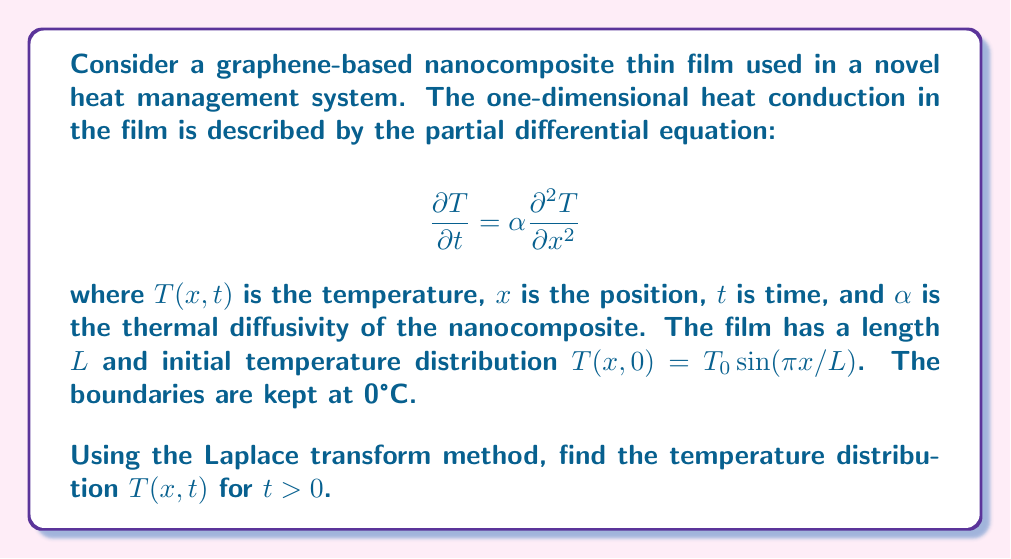What is the answer to this math problem? Let's solve this problem step by step using the Laplace transform method:

1) First, we apply the Laplace transform with respect to $t$ to the heat equation:

   $$\mathcal{L}\left\{\frac{\partial T}{\partial t}\right\} = \alpha \mathcal{L}\left\{\frac{\partial^2 T}{\partial x^2}\right\}$$

2) Using the Laplace transform properties:

   $$s\bar{T}(x,s) - T(x,0) = \alpha \frac{d^2 \bar{T}(x,s)}{dx^2}$$

   where $\bar{T}(x,s)$ is the Laplace transform of $T(x,t)$.

3) Substituting the initial condition:

   $$s\bar{T}(x,s) - T_0 \sin(\pi x/L) = \alpha \frac{d^2 \bar{T}(x,s)}{dx^2}$$

4) Rearranging:

   $$\frac{d^2 \bar{T}(x,s)}{dx^2} - \frac{s}{\alpha}\bar{T}(x,s) = -\frac{T_0}{\alpha} \sin(\pi x/L)$$

5) This is a non-homogeneous second-order ODE. Its general solution is the sum of the complementary function and a particular integral:

   $$\bar{T}(x,s) = A\sinh(\sqrt{\frac{s}{\alpha}}x) + B\cosh(\sqrt{\frac{s}{\alpha}}x) + \frac{T_0 \sin(\pi x/L)}{s + \alpha(\pi/L)^2}$$

6) Applying the boundary conditions $\bar{T}(0,s) = \bar{T}(L,s) = 0$:

   $$B = 0$$
   $$A\sinh(\sqrt{\frac{s}{\alpha}}L) + \frac{T_0 \sin(\pi)}{s + \alpha(\pi/L)^2} = 0$$

   The second equation is satisfied because $\sin(\pi) = 0$, so $A = 0$.

7) Therefore, the solution in the Laplace domain is:

   $$\bar{T}(x,s) = \frac{T_0 \sin(\pi x/L)}{s + \alpha(\pi/L)^2}$$

8) Taking the inverse Laplace transform:

   $$T(x,t) = T_0 \sin(\pi x/L) e^{-\alpha(\pi/L)^2 t}$$

This is the final solution for the temperature distribution.
Answer: $$T(x,t) = T_0 \sin(\pi x/L) e^{-\alpha(\pi/L)^2 t}$$ 